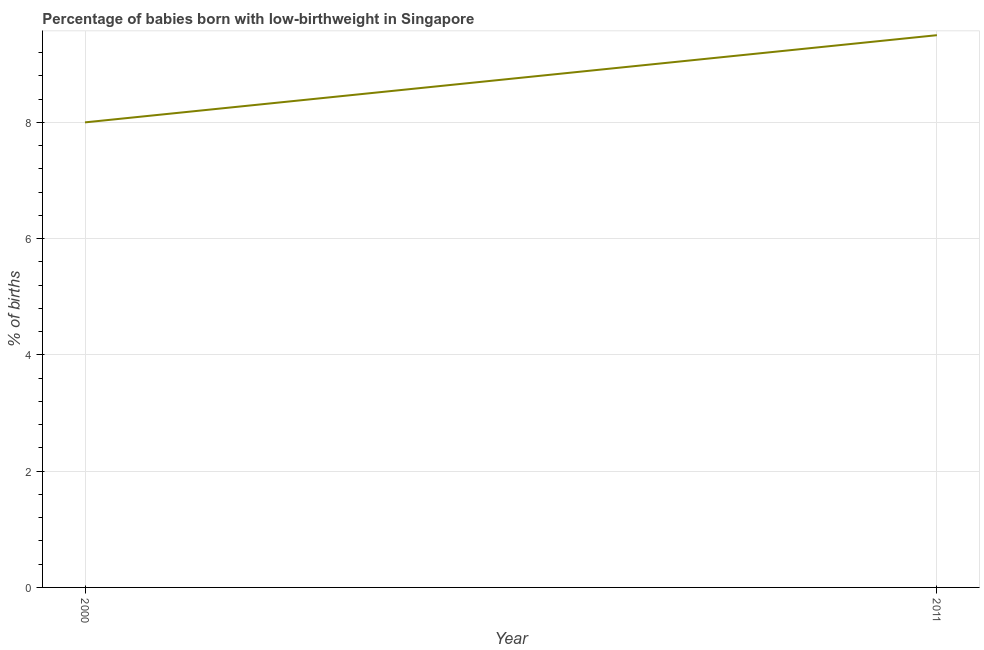Across all years, what is the maximum percentage of babies who were born with low-birthweight?
Ensure brevity in your answer.  9.5. Across all years, what is the minimum percentage of babies who were born with low-birthweight?
Offer a terse response. 8. In which year was the percentage of babies who were born with low-birthweight maximum?
Ensure brevity in your answer.  2011. What is the sum of the percentage of babies who were born with low-birthweight?
Your answer should be very brief. 17.5. What is the average percentage of babies who were born with low-birthweight per year?
Keep it short and to the point. 8.75. What is the median percentage of babies who were born with low-birthweight?
Offer a terse response. 8.75. What is the ratio of the percentage of babies who were born with low-birthweight in 2000 to that in 2011?
Offer a terse response. 0.84. Does the graph contain any zero values?
Make the answer very short. No. What is the title of the graph?
Offer a very short reply. Percentage of babies born with low-birthweight in Singapore. What is the label or title of the X-axis?
Provide a short and direct response. Year. What is the label or title of the Y-axis?
Make the answer very short. % of births. What is the % of births in 2000?
Make the answer very short. 8. What is the % of births in 2011?
Ensure brevity in your answer.  9.5. What is the difference between the % of births in 2000 and 2011?
Provide a short and direct response. -1.5. What is the ratio of the % of births in 2000 to that in 2011?
Give a very brief answer. 0.84. 